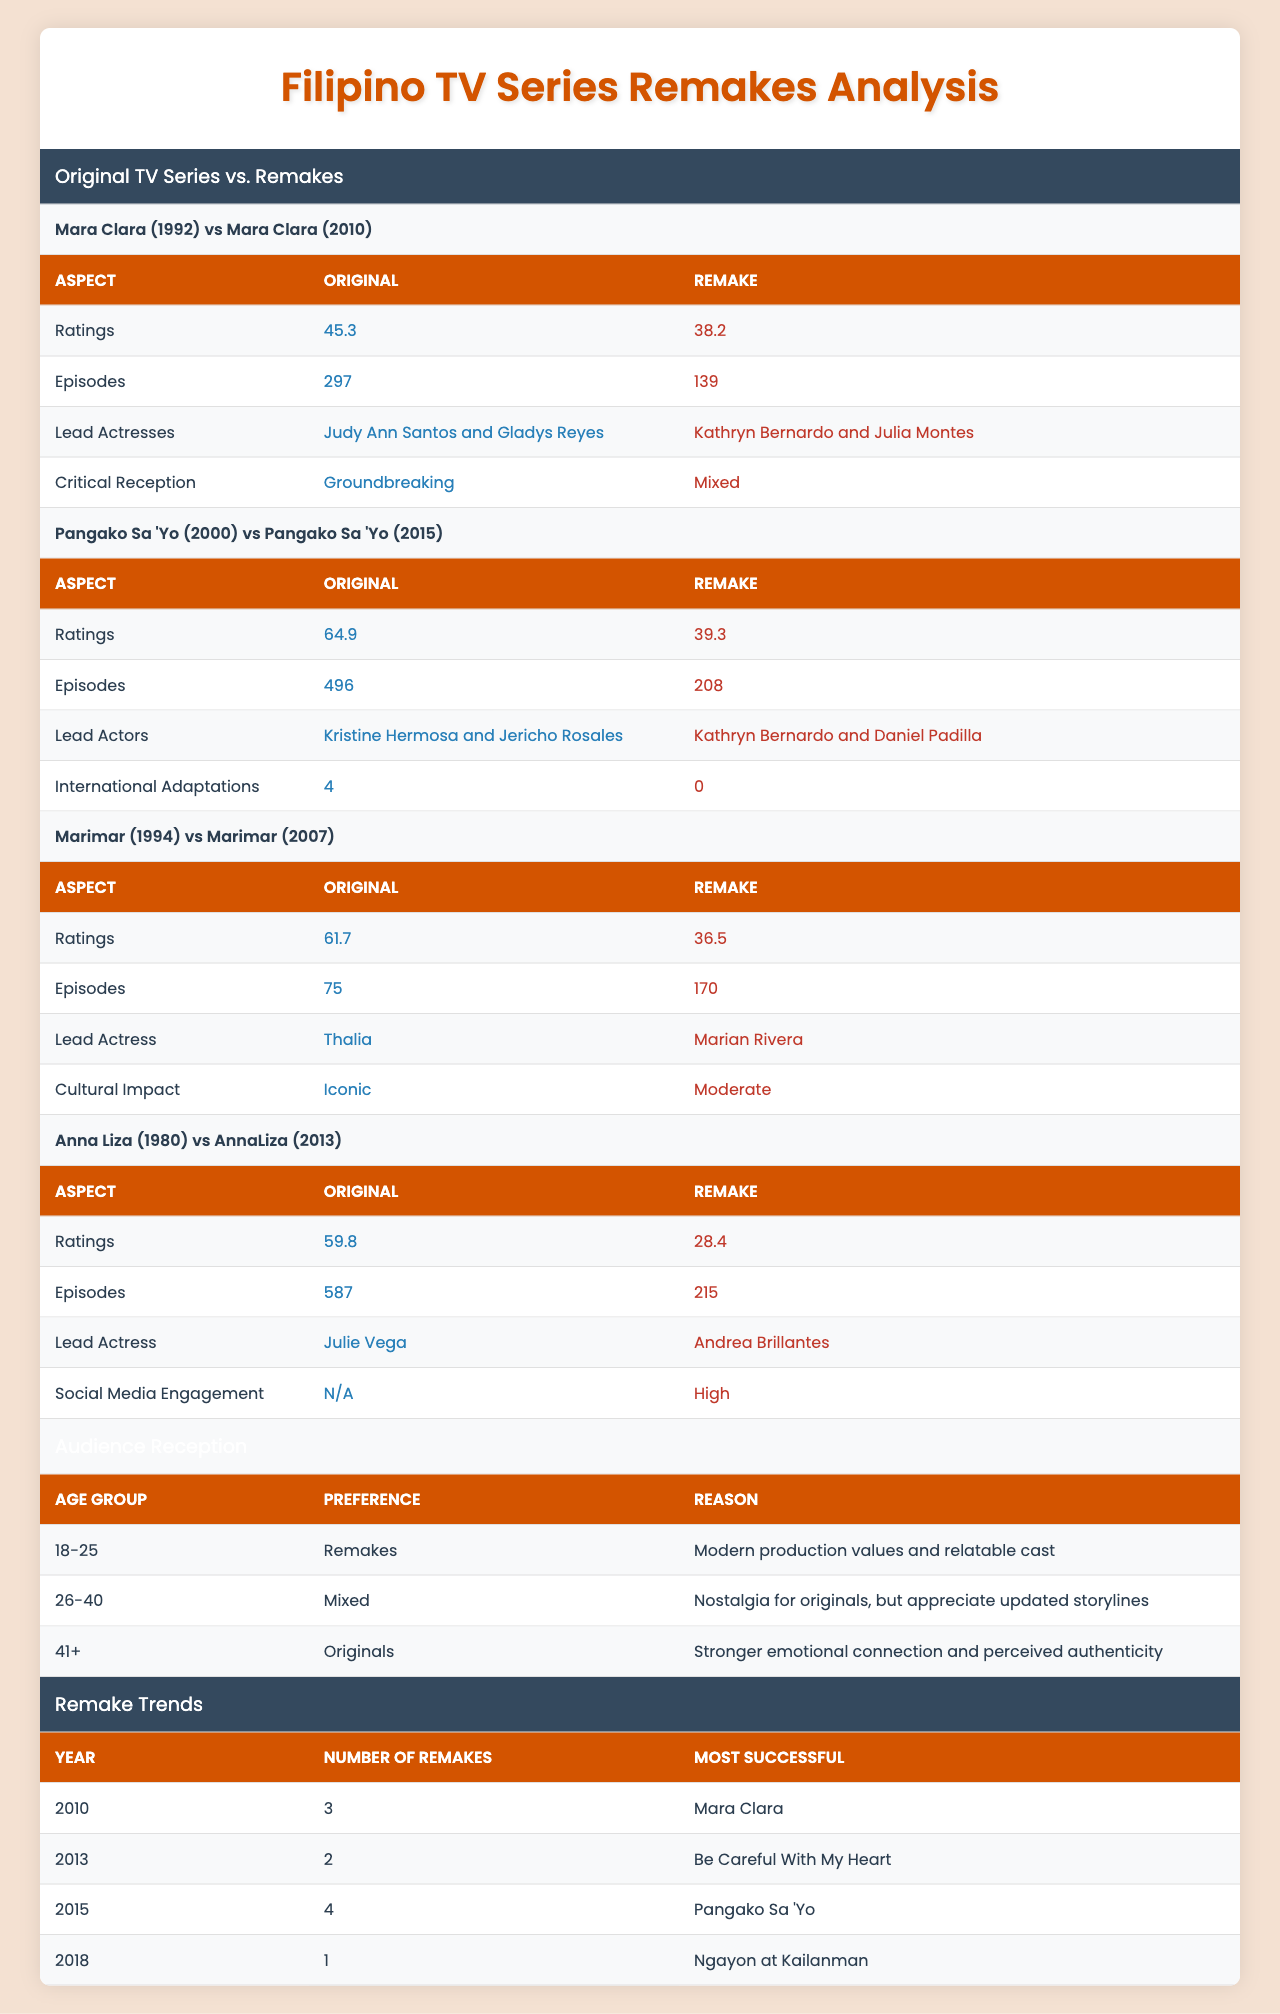What is the rating of the original series "Mara Clara"? The table indicates that the original "Mara Clara (1992)" has a rating of 45.3.
Answer: 45.3 How many episodes does the remake of "Pangako Sa 'Yo" have compared to the original? The original "Pangako Sa 'Yo (2000)" has 496 episodes and the remake has 208 episodes, which is a difference of 288 episodes.
Answer: 288 episodes Did "AnnaLiza (2013)" have a higher social media engagement compared to the original "Anna Liza (1980)"? The original series does not have a recorded engagement (N/A), while the remake had high social media engagement, indicating that the remake was engaged more on social platforms.
Answer: Yes What aspect has the most significant change in cultural impact between "Marimar (1994)" and its remake? The original "Marimar" is noted as iconic, while the remake's impact is classified as moderate, showing a decrease in cultural significance.
Answer: Significant decrease Which age group prefers remakes the most, according to audience reception? The table shows that the age group 18-25 prefers remakes due to modern production values and a relatable cast.
Answer: 18-25 What is the average rating of the original series compared to the remakes provided in the table? Calculate the average rating for original series: (45.3 + 64.9 + 61.7 + 59.8)/4 = 57.425 and for remakes: (38.2 + 39.3 + 36.5 + 28.4)/4 = 35.35. The average rating of original series is therefore 57.425.
Answer: 57.425 Which remake is the most successful in the year 2015 based on the number of remakes? The table indicates that in 2015, there were 4 remakes, and the most successful one is "Pangako Sa 'Yo."
Answer: Pangako Sa 'Yo How do the lead actresses of "Mara Clara" (original and remake) compare in terms of popularity? The original featured Judy Ann Santos and Gladys Reyes, while the remake had Kathryn Bernardo and Julia Montes, both of whom are popular among younger audiences today, but the original actresses had more groundbreaking recognition.
Answer: The original is more groundbreaking How many more episodes does the original "Anna Liza" series have than its remake? The original "Anna Liza (1980)" has 587 episodes while the remake "AnnaLiza (2013)" has 215 episodes. The difference is 372 episodes.
Answer: 372 episodes Based on the table, is it true that "Marimar" has more episodes in its remake than the original series? The original "Marimar" has 75 episodes while the remake has 170 episodes, confirming that the remake has more episodes.
Answer: True What year had the highest number of remakes according to the trends shown? In 2015, there were 4 remakes, the highest number reported in the data.
Answer: 2015 